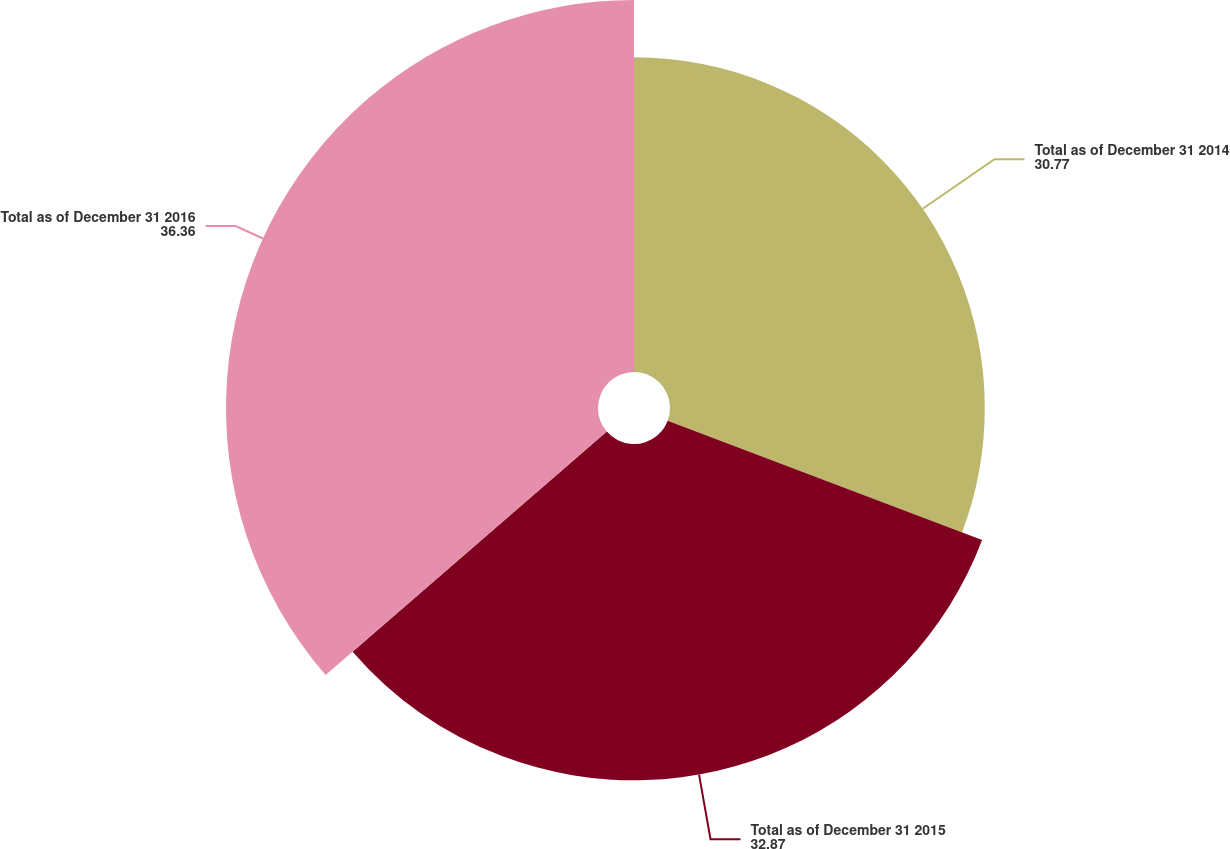<chart> <loc_0><loc_0><loc_500><loc_500><pie_chart><fcel>Total as of December 31 2014<fcel>Total as of December 31 2015<fcel>Total as of December 31 2016<nl><fcel>30.77%<fcel>32.87%<fcel>36.36%<nl></chart> 